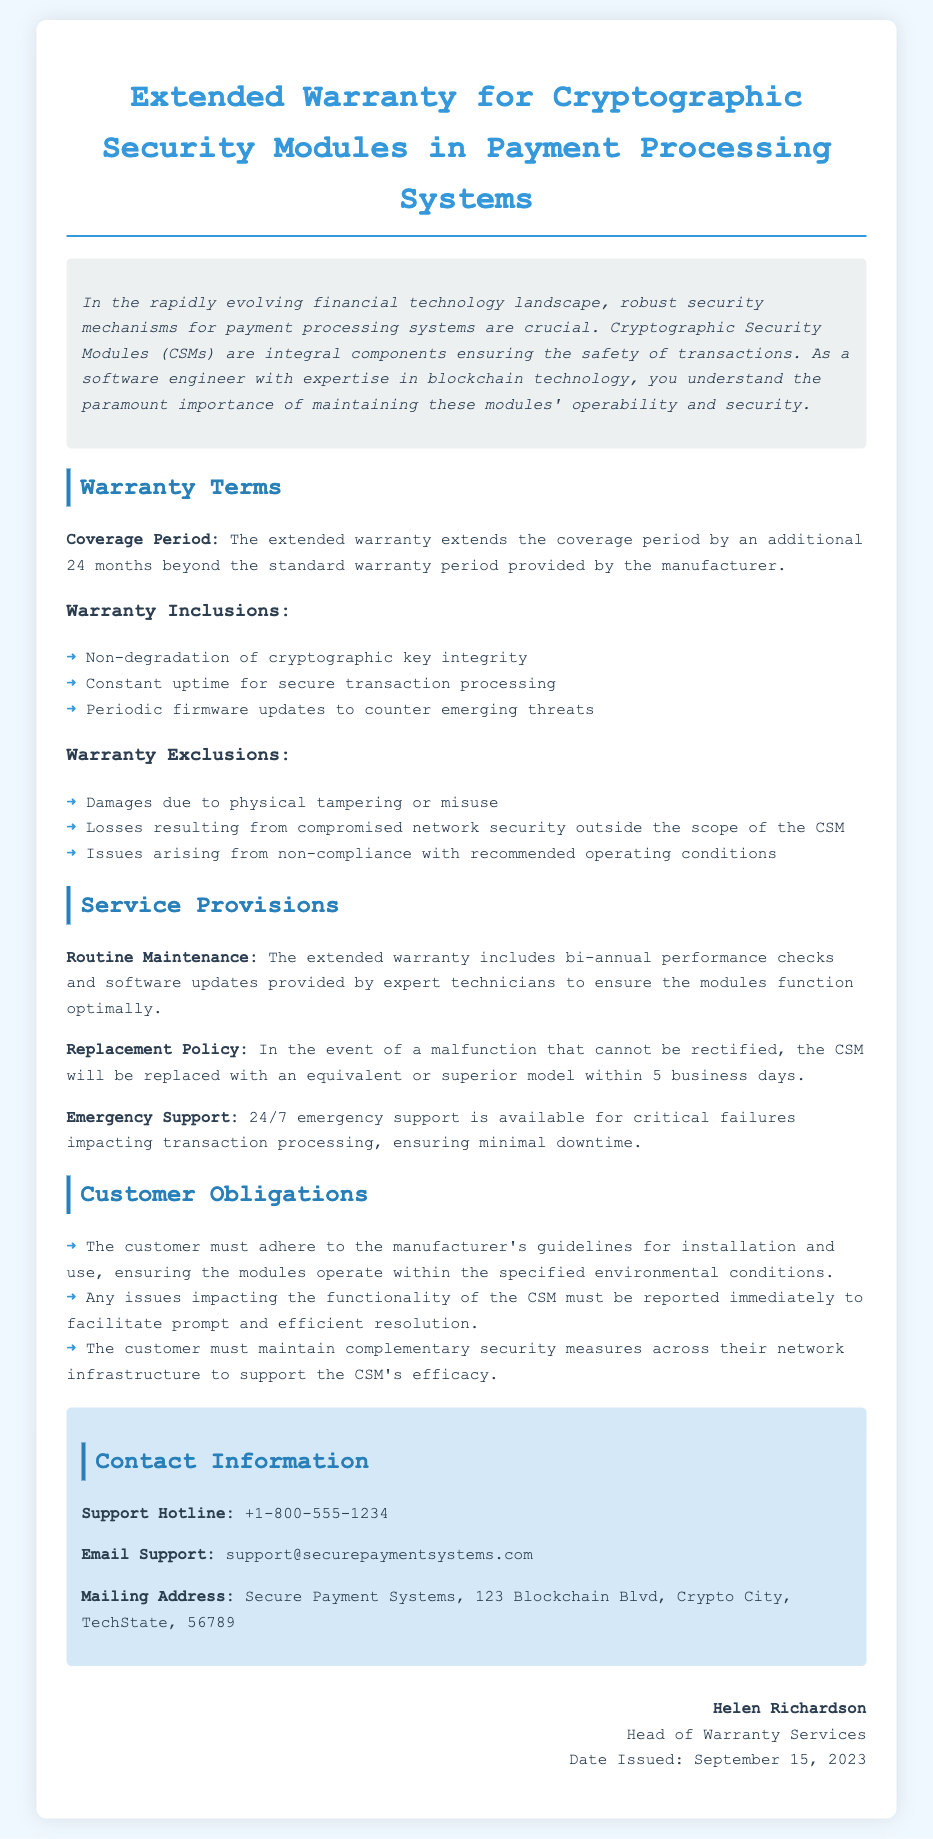what is the coverage period of the extended warranty? The coverage period is extended by an additional 24 months beyond the standard warranty period.
Answer: 24 months which damages are excluded under the warranty? Excluded damages are due to physical tampering or misuse.
Answer: physical tampering or misuse how often will performance checks be performed? Routine maintenance includes bi-annual performance checks, which means checks are done twice a year.
Answer: bi-annually what is the replacement policy time frame? If a CSM malfunctions, it will be replaced within 5 business days.
Answer: 5 business days who is the head of warranty services? The document specifies that Helen Richardson is the head of warranty services.
Answer: Helen Richardson what is the support hotline number? The support hotline number is provided for customer assistance.
Answer: +1-800-555-1234 why must the customer report issues immediately? Immediate reporting of issues facilitates prompt and efficient resolution.
Answer: prompt and efficient resolution what type of support is available for critical failures? The warranty includes 24/7 emergency support for critical failures impacting transaction processing.
Answer: 24/7 emergency support what must customers maintain to support the CSM's efficacy? Customers must maintain complementary security measures across their network infrastructure.
Answer: complementary security measures 